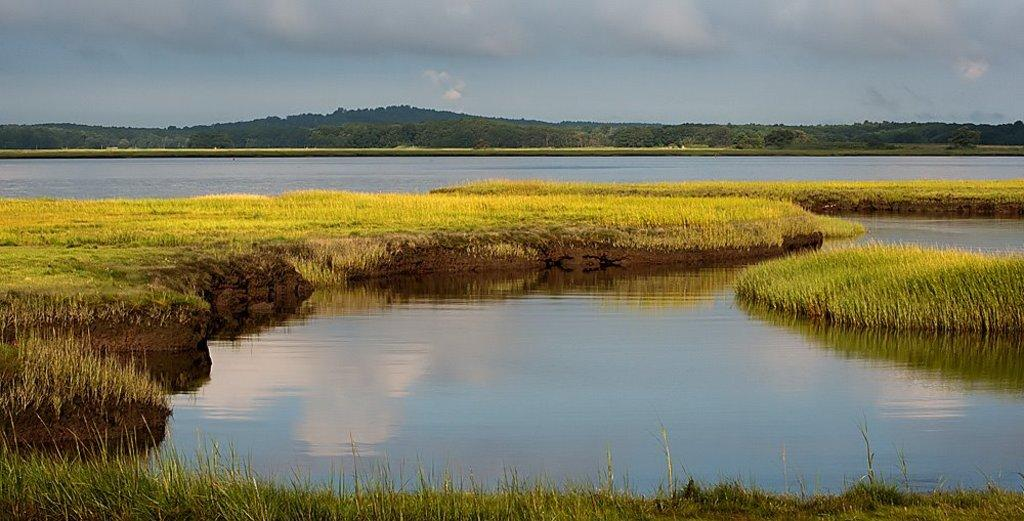Where was the image taken? The image was clicked outside. What is in the foreground of the image? There is a water body and grass in the foreground of the image. What can be seen in the background of the image? The sky, hills, trees, and other objects are visible in the background of the image. What type of yak can be seen grazing near the water body in the image? There is no yak present in the image; it features a water body, grass, and other natural elements. What sound can be heard during a thunderstorm in the image? There is no thunderstorm present in the image, and therefore no such sound can be heard. 